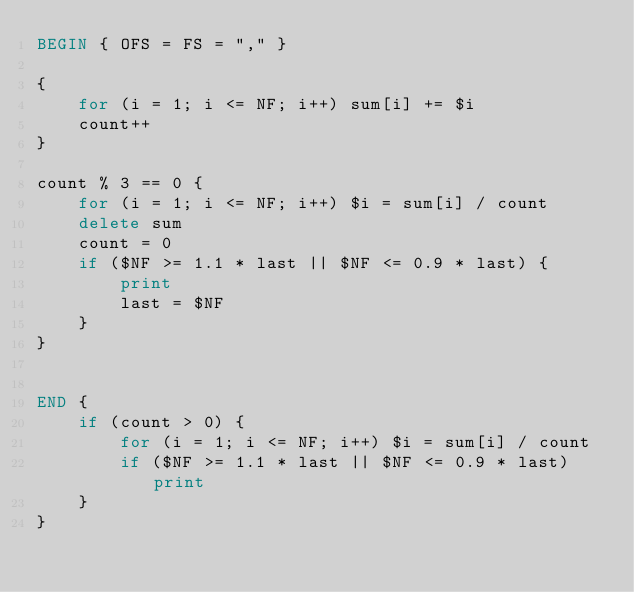Convert code to text. <code><loc_0><loc_0><loc_500><loc_500><_Awk_>BEGIN { OFS = FS = "," }

{
    for (i = 1; i <= NF; i++) sum[i] += $i
    count++
}

count % 3 == 0 {
    for (i = 1; i <= NF; i++) $i = sum[i] / count
    delete sum
    count = 0
    if ($NF >= 1.1 * last || $NF <= 0.9 * last) {
        print
        last = $NF
    }
}


END {
    if (count > 0) {
        for (i = 1; i <= NF; i++) $i = sum[i] / count
        if ($NF >= 1.1 * last || $NF <= 0.9 * last) print
    }
}
</code> 